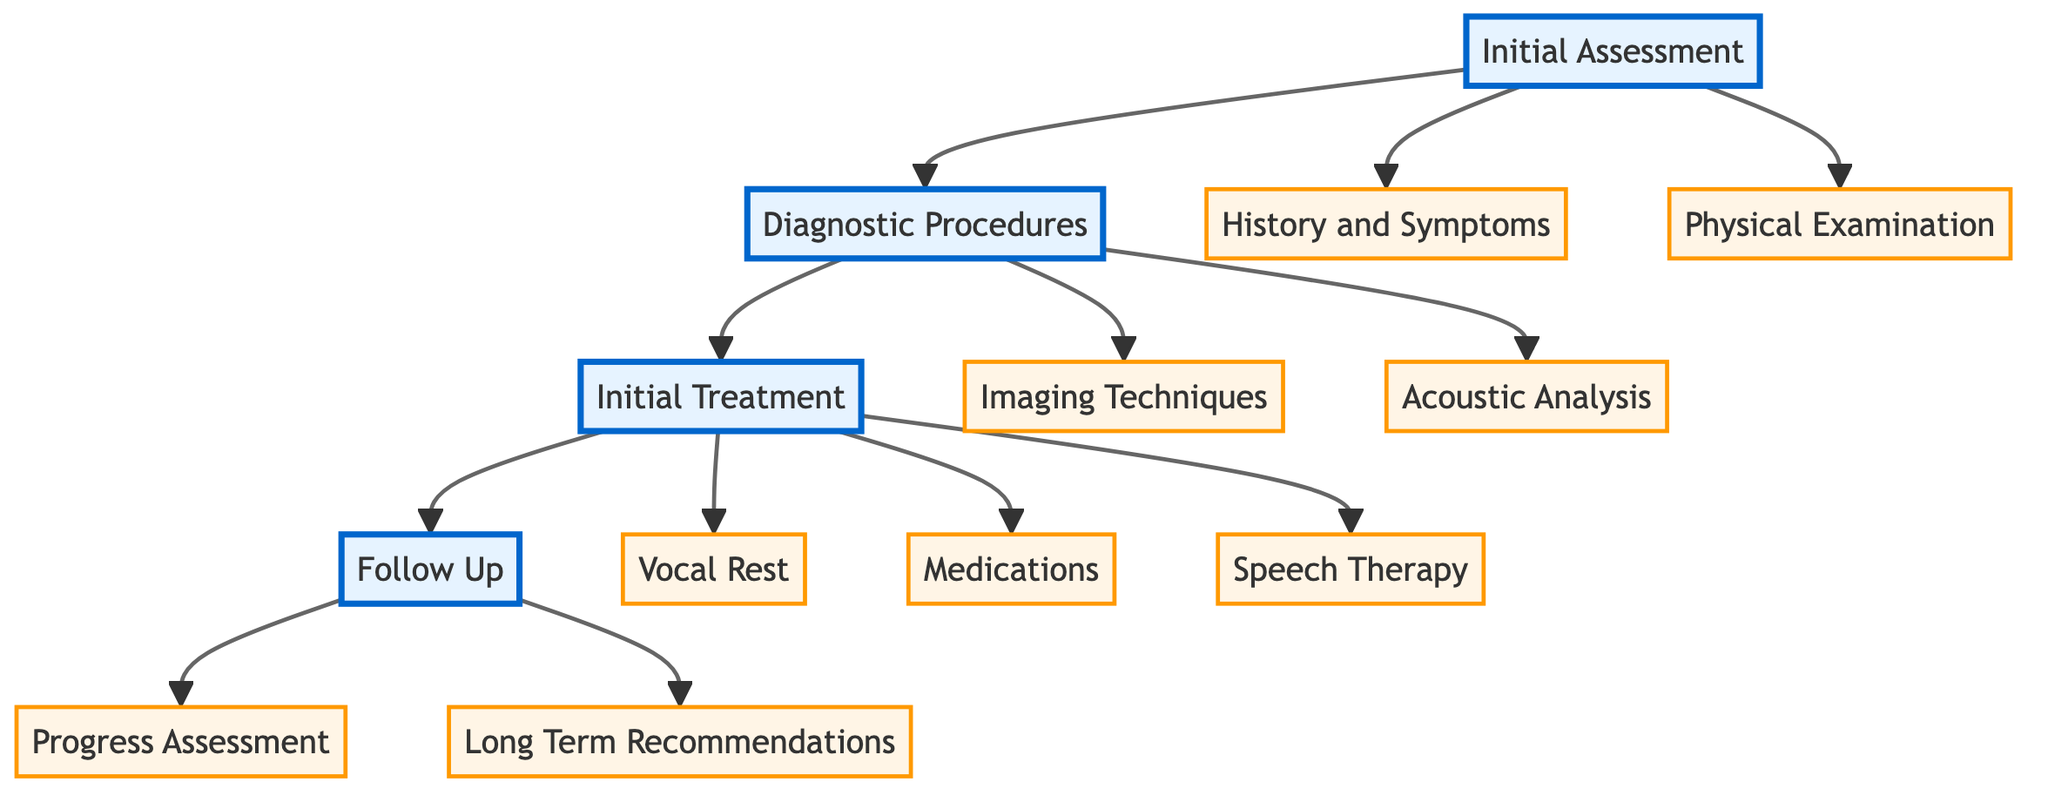What are the two main components of the Initial Assessment? The Initial Assessment consists of two main components: History and Symptoms, and Physical Examination. These components are the first nodes branching from the Initial Assessment node.
Answer: History and Symptoms, Physical Examination How many types of Diagnostic Procedures are listed in the diagram? The Diagnostic Procedures node contains two main types: Imaging Techniques and Acoustic Analysis. Each of these types branches out separately, resulting in two distinct categories.
Answer: 2 Which treatment modality follows Vocal Rest in the diagram? After the Vocal Rest node, the next treatment modality outlined in the diagram is Medications. This follows the sequence from Initial Treatment.
Answer: Medications What is included in Speech Therapy? Speech Therapy comprises three elements: Vocal Hygiene Education, Resonant Voice Therapy, and Semi-Occluded Vocal Tract Exercises, which are all categorized under the Speech Therapy node in the Initial Treatment section.
Answer: Vocal Hygiene Education, Resonant Voice Therapy, Semi-Occluded Vocal Tract Exercises How does the Assessment and Follow-up process flow? The flow starts from Initial Assessment leading to Diagnostic Procedures, followed by Initial Treatment, and concludes with Follow Up. This order shows the progression from assessment to follow-up care.
Answer: Initial Assessment → Diagnostic Procedures → Initial Treatment → Follow Up What is the purpose of the Long Term Recommendations? Long Term Recommendations serve to provide ongoing guidance post-treatment, emphasizing the need for regular voice check-ups and the importance of using proper vocal techniques. It reflects the essential strategies needed for maintaining vocal health.
Answer: Regular Voice Check-Ups, Continued Use of Proper Vocal Techniques, Stress Management and Relaxation Techniques 